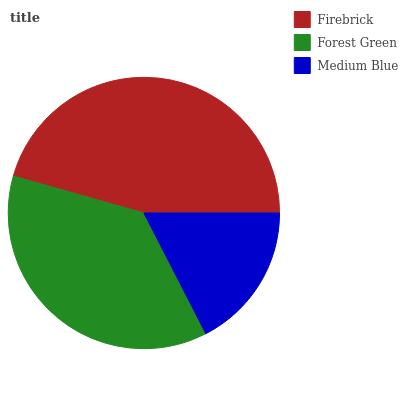Is Medium Blue the minimum?
Answer yes or no. Yes. Is Firebrick the maximum?
Answer yes or no. Yes. Is Forest Green the minimum?
Answer yes or no. No. Is Forest Green the maximum?
Answer yes or no. No. Is Firebrick greater than Forest Green?
Answer yes or no. Yes. Is Forest Green less than Firebrick?
Answer yes or no. Yes. Is Forest Green greater than Firebrick?
Answer yes or no. No. Is Firebrick less than Forest Green?
Answer yes or no. No. Is Forest Green the high median?
Answer yes or no. Yes. Is Forest Green the low median?
Answer yes or no. Yes. Is Firebrick the high median?
Answer yes or no. No. Is Firebrick the low median?
Answer yes or no. No. 